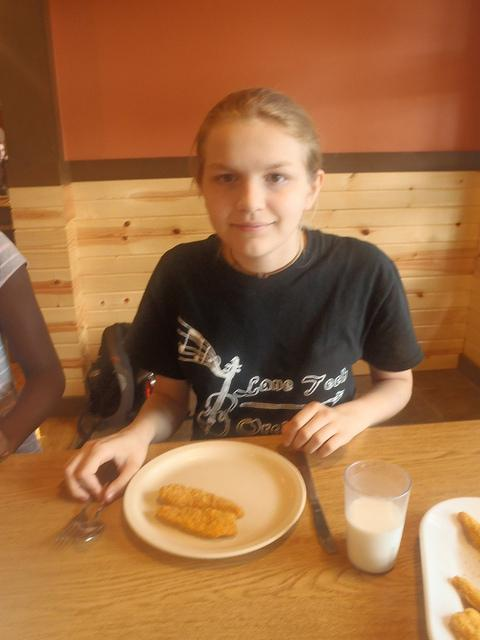What side dish would compliment his food quite well?

Choices:
A) soup
B) apples
C) fries
D) milk fries 